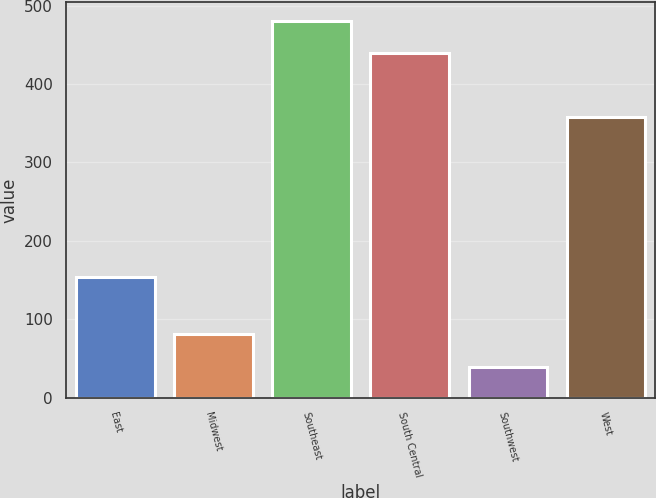Convert chart. <chart><loc_0><loc_0><loc_500><loc_500><bar_chart><fcel>East<fcel>Midwest<fcel>Southeast<fcel>South Central<fcel>Southwest<fcel>West<nl><fcel>153.9<fcel>80.67<fcel>480.17<fcel>439.1<fcel>39.6<fcel>357.3<nl></chart> 